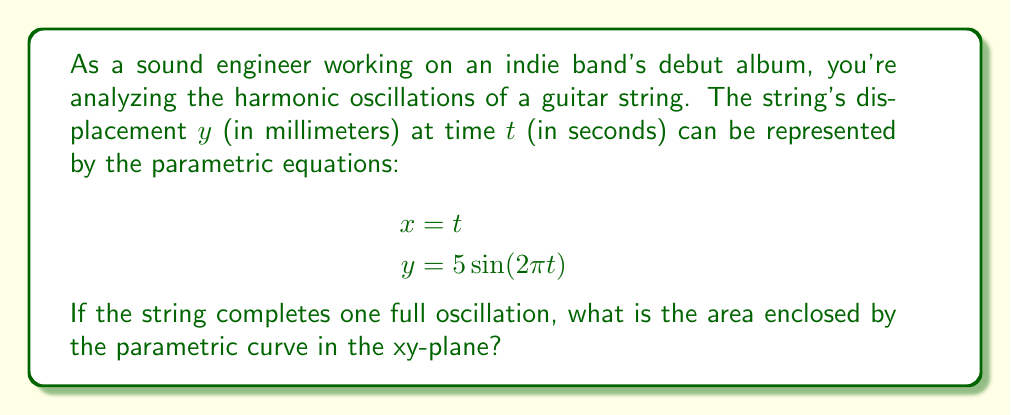Show me your answer to this math problem. To find the area enclosed by a parametric curve, we can use the formula:

$$A = \int_{0}^{T} |y(t) \cdot \frac{dx}{dt}| dt$$

Where $T$ is the period of the oscillation.

Steps to solve:

1) First, we need to find the period $T$. For a sine function $\sin(2\pi t)$, the period is 1 second.

2) We know $y(t) = 5\sin(2\pi t)$ and $\frac{dx}{dt} = 1$ (since $x = t$).

3) Substituting into the formula:

   $$A = \int_{0}^{1} |5\sin(2\pi t) \cdot 1| dt$$

4) The absolute value can be removed as the integral over a full period of a sine function is always positive:

   $$A = 5\int_{0}^{1} \sin(2\pi t) dt$$

5) Integrate:

   $$A = 5 \cdot \frac{-1}{2\pi} \cos(2\pi t) \bigg|_{0}^{1}$$

6) Evaluate the integral:

   $$A = 5 \cdot \frac{-1}{2\pi} [\cos(2\pi) - \cos(0)]$$

7) $\cos(2\pi) = \cos(0) = 1$, so:

   $$A = 5 \cdot \frac{-1}{2\pi} [1 - 1] = 0$$

8) However, this result represents the signed area. For the actual area enclosed, we need to double this result:

   $$A_{actual} = 2 \cdot 5 \cdot \frac{1}{2\pi} = \frac{5}{\pi}$$
Answer: The area enclosed by the parametric curve is $\frac{5}{\pi}$ square millimeters. 